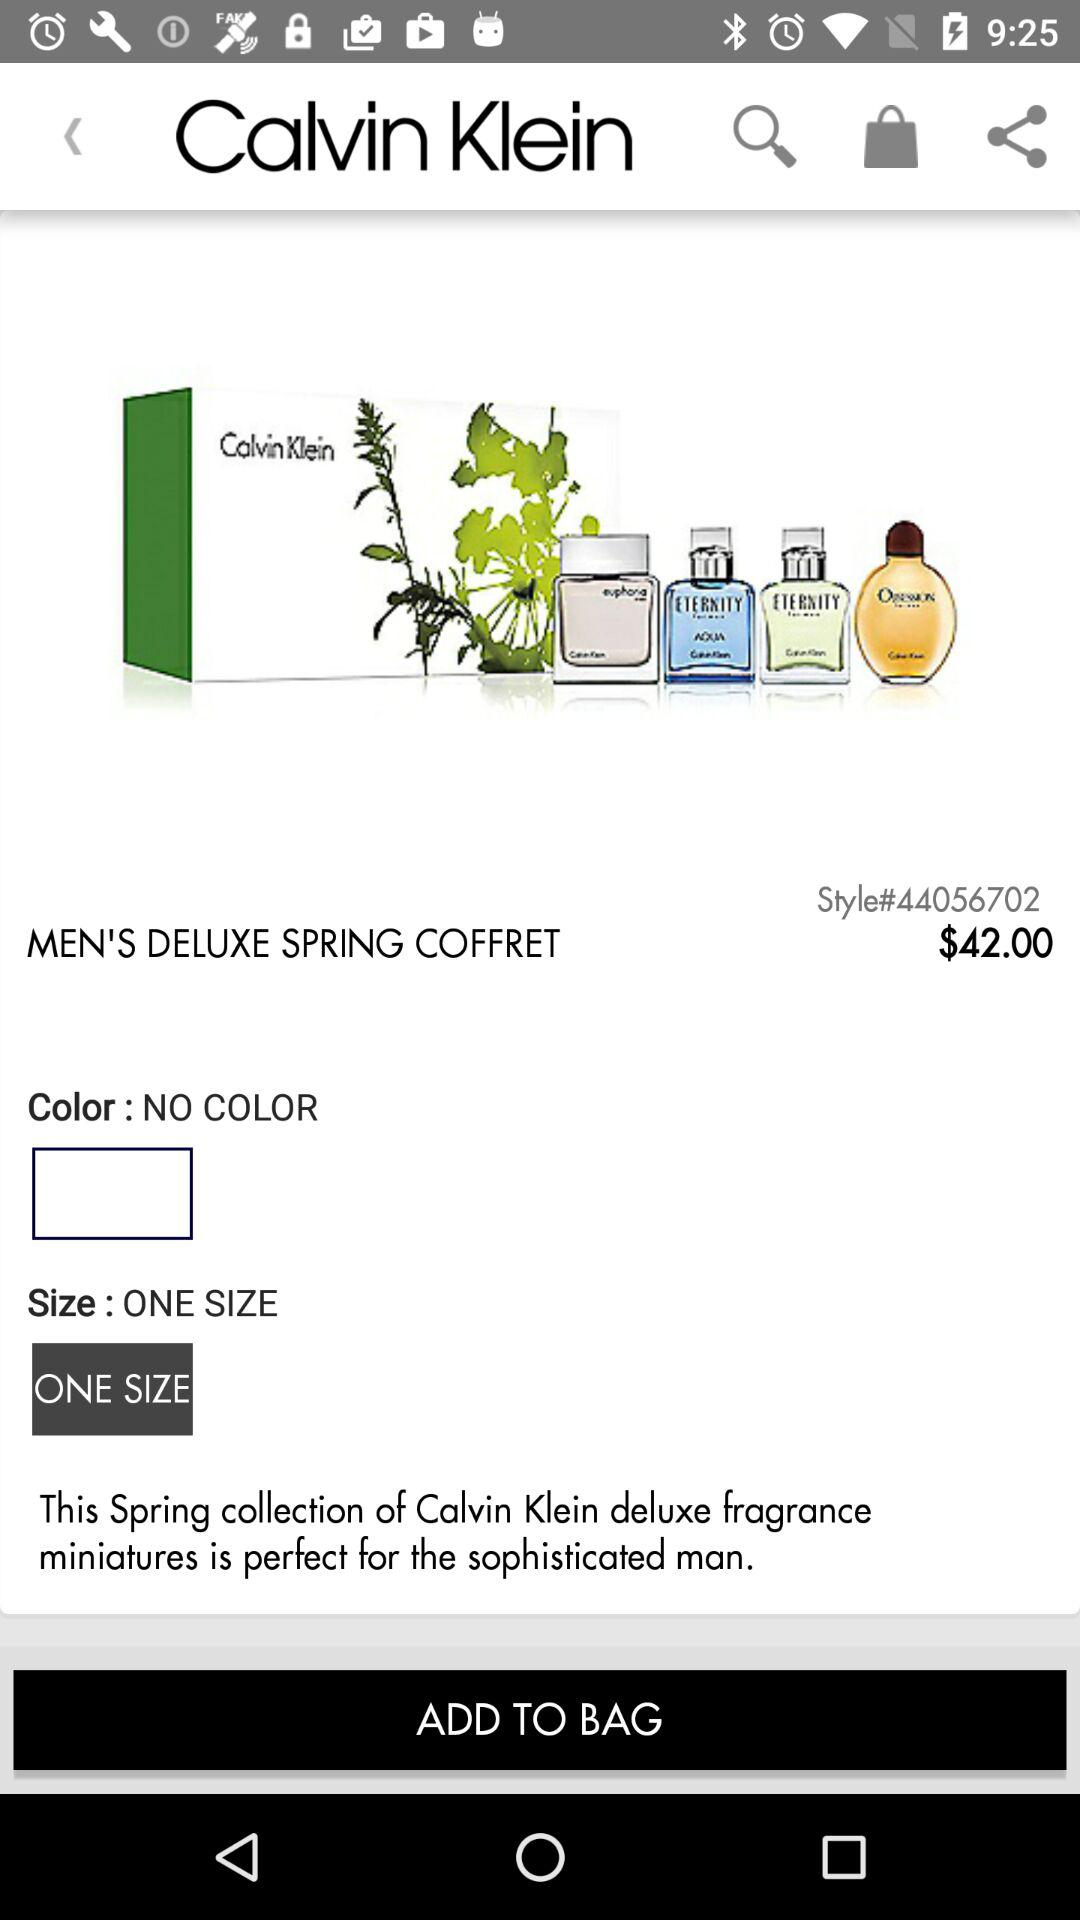What is the company name of the perfumes? The company name of the perfumes is Calvin Klein. 